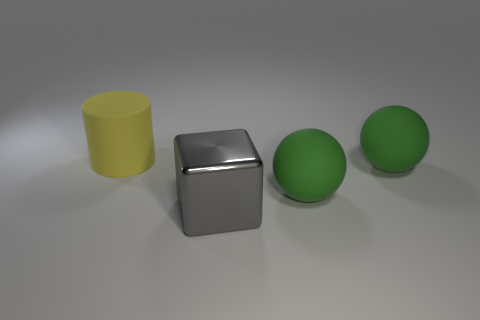Add 3 large yellow objects. How many objects exist? 7 Subtract all cylinders. How many objects are left? 3 Add 2 red rubber cylinders. How many red rubber cylinders exist? 2 Subtract 0 red spheres. How many objects are left? 4 Subtract 1 spheres. How many spheres are left? 1 Subtract all yellow spheres. Subtract all blue cylinders. How many spheres are left? 2 Subtract all large purple shiny balls. Subtract all big gray objects. How many objects are left? 3 Add 1 big yellow things. How many big yellow things are left? 2 